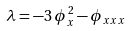Convert formula to latex. <formula><loc_0><loc_0><loc_500><loc_500>\lambda = - 3 \, \phi _ { x } ^ { \, 2 } - \phi _ { x x x }</formula> 